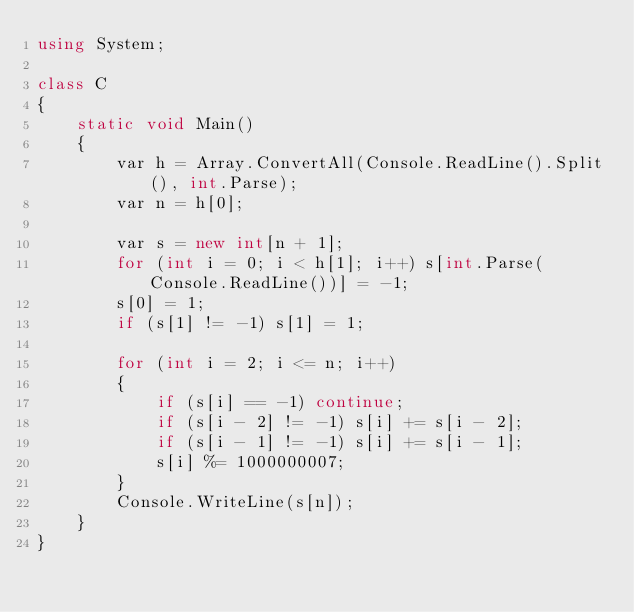Convert code to text. <code><loc_0><loc_0><loc_500><loc_500><_C#_>using System;

class C
{
	static void Main()
	{
		var h = Array.ConvertAll(Console.ReadLine().Split(), int.Parse);
		var n = h[0];

		var s = new int[n + 1];
		for (int i = 0; i < h[1]; i++) s[int.Parse(Console.ReadLine())] = -1;
		s[0] = 1;
		if (s[1] != -1) s[1] = 1;

		for (int i = 2; i <= n; i++)
		{
			if (s[i] == -1) continue;
			if (s[i - 2] != -1) s[i] += s[i - 2];
			if (s[i - 1] != -1) s[i] += s[i - 1];
			s[i] %= 1000000007;
		}
		Console.WriteLine(s[n]);
	}
}
</code> 